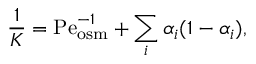Convert formula to latex. <formula><loc_0><loc_0><loc_500><loc_500>\frac { 1 } { K } = P e _ { o s m } ^ { - 1 } + \sum _ { i } \alpha _ { i } ( 1 - \alpha _ { i } ) ,</formula> 